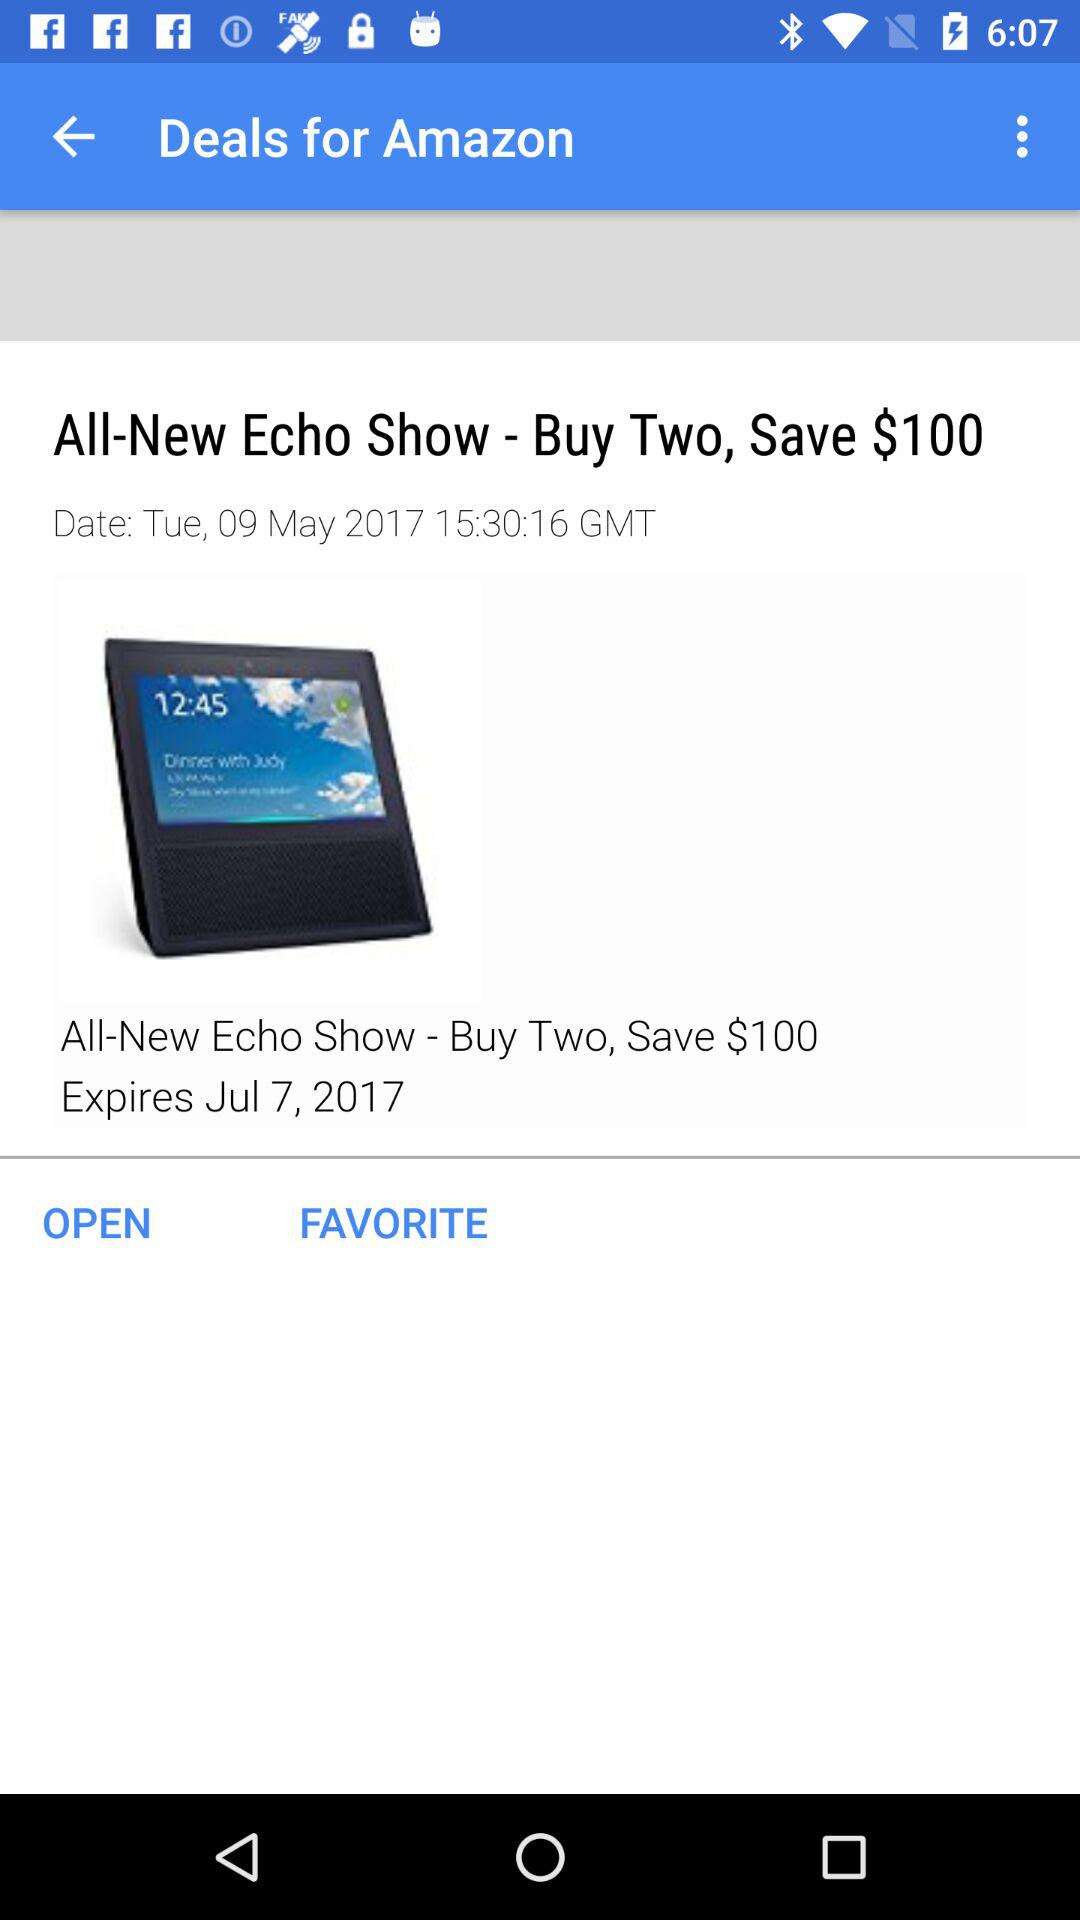What is the expiration date? The expiration date is July 7, 2017. 